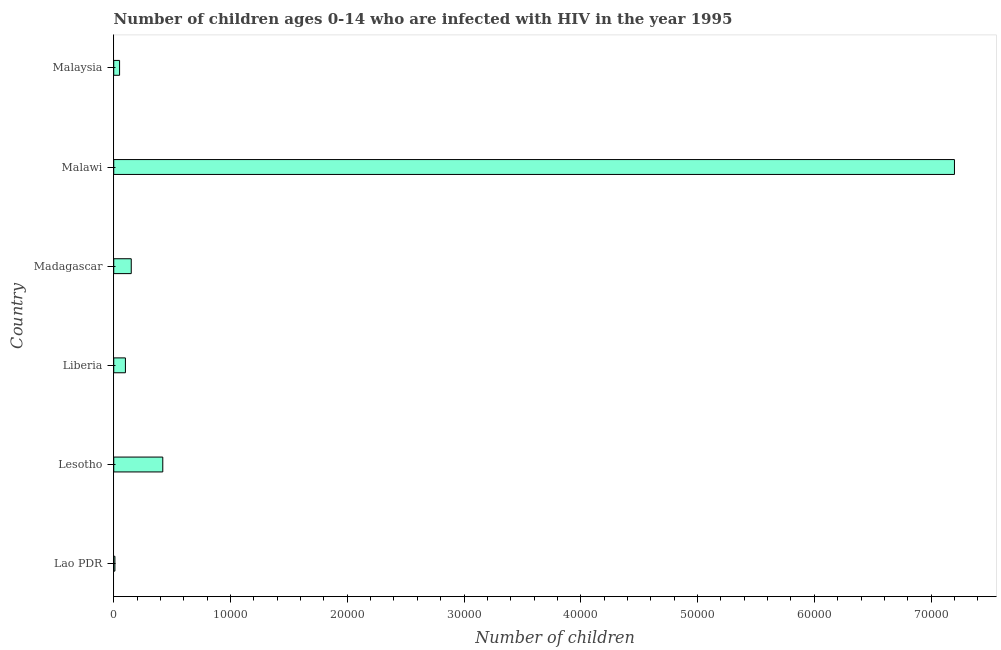Does the graph contain grids?
Your response must be concise. No. What is the title of the graph?
Offer a terse response. Number of children ages 0-14 who are infected with HIV in the year 1995. What is the label or title of the X-axis?
Offer a terse response. Number of children. What is the number of children living with hiv in Madagascar?
Keep it short and to the point. 1500. Across all countries, what is the maximum number of children living with hiv?
Make the answer very short. 7.20e+04. Across all countries, what is the minimum number of children living with hiv?
Make the answer very short. 100. In which country was the number of children living with hiv maximum?
Your answer should be very brief. Malawi. In which country was the number of children living with hiv minimum?
Keep it short and to the point. Lao PDR. What is the sum of the number of children living with hiv?
Offer a very short reply. 7.93e+04. What is the difference between the number of children living with hiv in Lao PDR and Liberia?
Offer a terse response. -900. What is the average number of children living with hiv per country?
Your answer should be very brief. 1.32e+04. What is the median number of children living with hiv?
Make the answer very short. 1250. What is the ratio of the number of children living with hiv in Lesotho to that in Malawi?
Provide a short and direct response. 0.06. Is the number of children living with hiv in Madagascar less than that in Malawi?
Give a very brief answer. Yes. What is the difference between the highest and the second highest number of children living with hiv?
Your answer should be compact. 6.78e+04. Is the sum of the number of children living with hiv in Malawi and Malaysia greater than the maximum number of children living with hiv across all countries?
Provide a succinct answer. Yes. What is the difference between the highest and the lowest number of children living with hiv?
Keep it short and to the point. 7.19e+04. In how many countries, is the number of children living with hiv greater than the average number of children living with hiv taken over all countries?
Ensure brevity in your answer.  1. Are all the bars in the graph horizontal?
Your answer should be compact. Yes. How many countries are there in the graph?
Provide a succinct answer. 6. What is the Number of children in Lesotho?
Offer a terse response. 4200. What is the Number of children of Madagascar?
Provide a short and direct response. 1500. What is the Number of children of Malawi?
Give a very brief answer. 7.20e+04. What is the difference between the Number of children in Lao PDR and Lesotho?
Provide a short and direct response. -4100. What is the difference between the Number of children in Lao PDR and Liberia?
Your answer should be compact. -900. What is the difference between the Number of children in Lao PDR and Madagascar?
Give a very brief answer. -1400. What is the difference between the Number of children in Lao PDR and Malawi?
Your response must be concise. -7.19e+04. What is the difference between the Number of children in Lao PDR and Malaysia?
Provide a succinct answer. -400. What is the difference between the Number of children in Lesotho and Liberia?
Your answer should be very brief. 3200. What is the difference between the Number of children in Lesotho and Madagascar?
Provide a succinct answer. 2700. What is the difference between the Number of children in Lesotho and Malawi?
Provide a short and direct response. -6.78e+04. What is the difference between the Number of children in Lesotho and Malaysia?
Provide a short and direct response. 3700. What is the difference between the Number of children in Liberia and Madagascar?
Your answer should be compact. -500. What is the difference between the Number of children in Liberia and Malawi?
Your response must be concise. -7.10e+04. What is the difference between the Number of children in Liberia and Malaysia?
Your answer should be very brief. 500. What is the difference between the Number of children in Madagascar and Malawi?
Your answer should be compact. -7.05e+04. What is the difference between the Number of children in Malawi and Malaysia?
Your answer should be very brief. 7.15e+04. What is the ratio of the Number of children in Lao PDR to that in Lesotho?
Make the answer very short. 0.02. What is the ratio of the Number of children in Lao PDR to that in Liberia?
Make the answer very short. 0.1. What is the ratio of the Number of children in Lao PDR to that in Madagascar?
Provide a short and direct response. 0.07. What is the ratio of the Number of children in Lao PDR to that in Malaysia?
Your answer should be compact. 0.2. What is the ratio of the Number of children in Lesotho to that in Madagascar?
Offer a terse response. 2.8. What is the ratio of the Number of children in Lesotho to that in Malawi?
Your response must be concise. 0.06. What is the ratio of the Number of children in Lesotho to that in Malaysia?
Provide a succinct answer. 8.4. What is the ratio of the Number of children in Liberia to that in Madagascar?
Keep it short and to the point. 0.67. What is the ratio of the Number of children in Liberia to that in Malawi?
Your answer should be very brief. 0.01. What is the ratio of the Number of children in Liberia to that in Malaysia?
Offer a terse response. 2. What is the ratio of the Number of children in Madagascar to that in Malawi?
Your response must be concise. 0.02. What is the ratio of the Number of children in Malawi to that in Malaysia?
Offer a terse response. 144. 